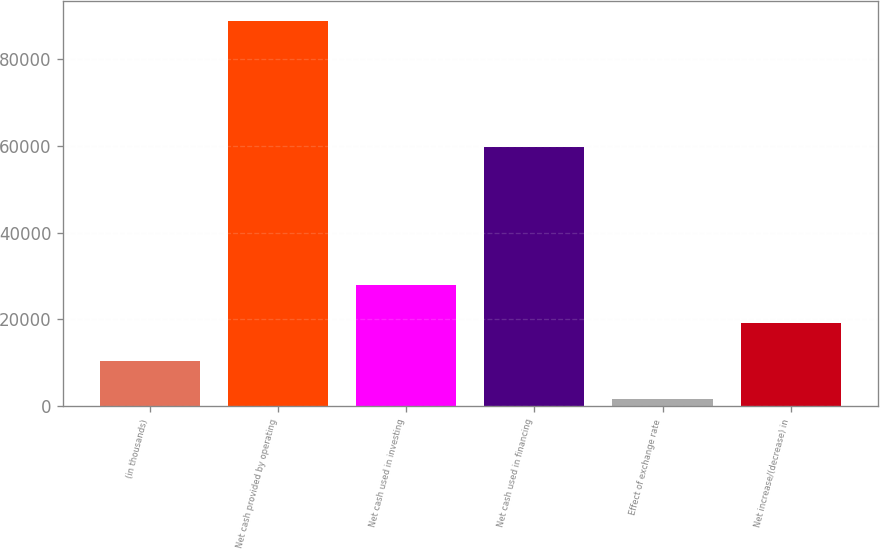<chart> <loc_0><loc_0><loc_500><loc_500><bar_chart><fcel>(in thousands)<fcel>Net cash provided by operating<fcel>Net cash used in investing<fcel>Net cash used in financing<fcel>Effect of exchange rate<fcel>Net increase/(decrease) in<nl><fcel>10429.6<fcel>88762<fcel>27836.8<fcel>59798<fcel>1726<fcel>19133.2<nl></chart> 